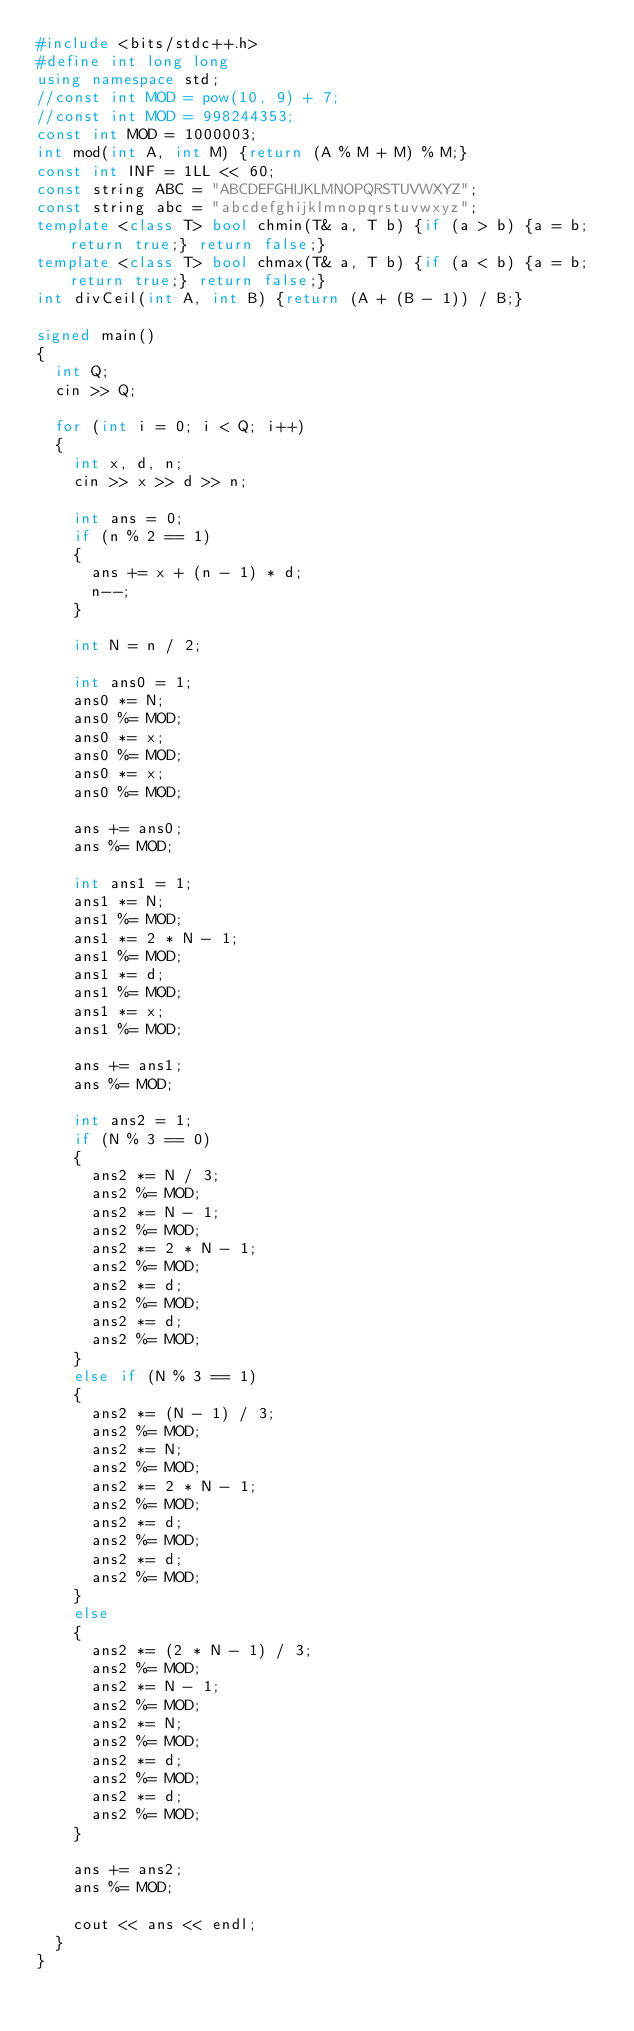<code> <loc_0><loc_0><loc_500><loc_500><_C++_>#include <bits/stdc++.h>
#define int long long
using namespace std;
//const int MOD = pow(10, 9) + 7;
//const int MOD = 998244353;
const int MOD = 1000003;
int mod(int A, int M) {return (A % M + M) % M;}
const int INF = 1LL << 60;
const string ABC = "ABCDEFGHIJKLMNOPQRSTUVWXYZ";
const string abc = "abcdefghijklmnopqrstuvwxyz";
template <class T> bool chmin(T& a, T b) {if (a > b) {a = b; return true;} return false;}
template <class T> bool chmax(T& a, T b) {if (a < b) {a = b; return true;} return false;}
int divCeil(int A, int B) {return (A + (B - 1)) / B;}

signed main()
{
  int Q;
  cin >> Q;

  for (int i = 0; i < Q; i++)
  {
    int x, d, n;
    cin >> x >> d >> n;

    int ans = 0;
    if (n % 2 == 1) 
    {
      ans += x + (n - 1) * d;
      n--;
    }
    
    int N = n / 2;

    int ans0 = 1;
    ans0 *= N;
    ans0 %= MOD;
    ans0 *= x;
    ans0 %= MOD;
    ans0 *= x;
    ans0 %= MOD;

    ans += ans0;
    ans %= MOD;

    int ans1 = 1;
    ans1 *= N;
    ans1 %= MOD;
    ans1 *= 2 * N - 1;
    ans1 %= MOD;
    ans1 *= d;
    ans1 %= MOD;
    ans1 *= x;
    ans1 %= MOD;

    ans += ans1;
    ans %= MOD;

    int ans2 = 1;
    if (N % 3 == 0)
    {
      ans2 *= N / 3;
      ans2 %= MOD;
      ans2 *= N - 1;
      ans2 %= MOD;
      ans2 *= 2 * N - 1;
      ans2 %= MOD;
      ans2 *= d;
      ans2 %= MOD;
      ans2 *= d;
      ans2 %= MOD;
    }
    else if (N % 3 == 1)
    {
      ans2 *= (N - 1) / 3;
      ans2 %= MOD;
      ans2 *= N;
      ans2 %= MOD;
      ans2 *= 2 * N - 1;
      ans2 %= MOD;
      ans2 *= d;
      ans2 %= MOD;
      ans2 *= d;
      ans2 %= MOD;
    }
    else
    {
      ans2 *= (2 * N - 1) / 3;
      ans2 %= MOD;
      ans2 *= N - 1;
      ans2 %= MOD;
      ans2 *= N;
      ans2 %= MOD;
      ans2 *= d;
      ans2 %= MOD;
      ans2 *= d;
      ans2 %= MOD;
    }
    
    ans += ans2;
    ans %= MOD;

    cout << ans << endl;
  }
}</code> 